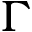Convert formula to latex. <formula><loc_0><loc_0><loc_500><loc_500>\Gamma</formula> 